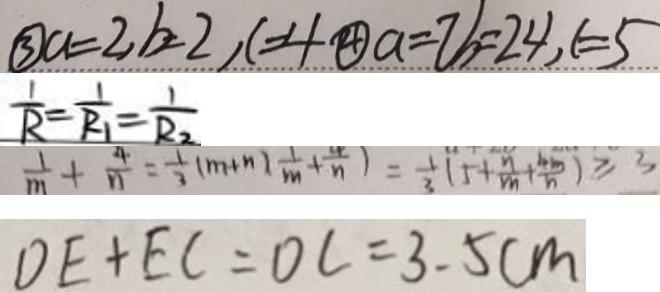Convert formula to latex. <formula><loc_0><loc_0><loc_500><loc_500>\textcircled { 3 } a = 2 , b = 2 , c = 4 \textcircled { 4 } a = 7 b = 2 4 , c = 5 
 \frac { 1 } { R } = \frac { 1 } { R _ { 1 } } = \frac { 1 } { R _ { 2 } } 
 \frac { 1 } { m } + \frac { 4 } { n } = \frac { 1 } { 3 } ( m + n ) \frac { 1 } { m } + \frac { 4 } { n } + \frac { 4 } { n } ) = \frac { 1 } { 3 } ( 5 + \frac { n } { m } + \frac { 4 m } { n } ) \geq 3 
 D E + E C = D C = 3 . 5 c m</formula> 